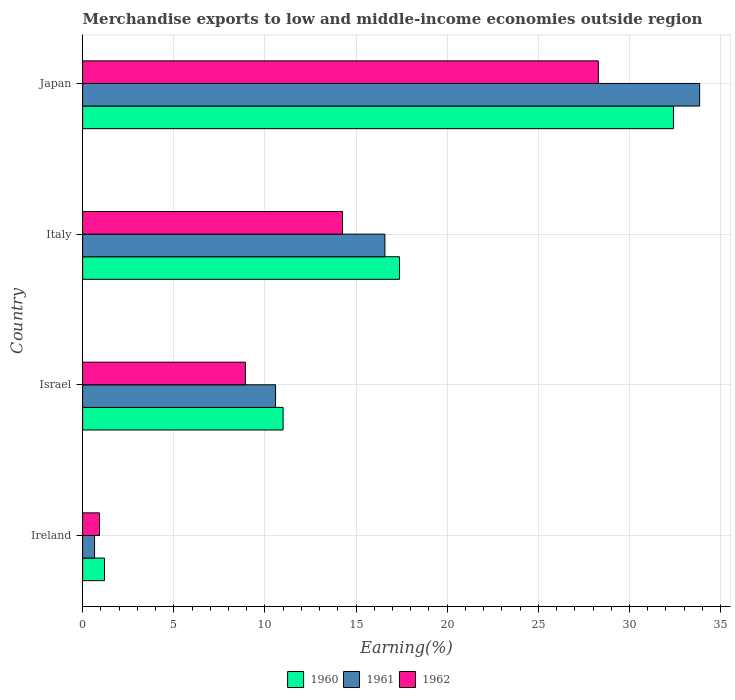How many different coloured bars are there?
Your answer should be compact. 3. Are the number of bars per tick equal to the number of legend labels?
Your answer should be compact. Yes. What is the label of the 3rd group of bars from the top?
Provide a succinct answer. Israel. What is the percentage of amount earned from merchandise exports in 1960 in Japan?
Offer a very short reply. 32.41. Across all countries, what is the maximum percentage of amount earned from merchandise exports in 1960?
Provide a succinct answer. 32.41. Across all countries, what is the minimum percentage of amount earned from merchandise exports in 1960?
Your response must be concise. 1.2. In which country was the percentage of amount earned from merchandise exports in 1962 minimum?
Your response must be concise. Ireland. What is the total percentage of amount earned from merchandise exports in 1961 in the graph?
Provide a short and direct response. 61.67. What is the difference between the percentage of amount earned from merchandise exports in 1962 in Ireland and that in Italy?
Provide a succinct answer. -13.33. What is the difference between the percentage of amount earned from merchandise exports in 1961 in Italy and the percentage of amount earned from merchandise exports in 1962 in Ireland?
Make the answer very short. 15.66. What is the average percentage of amount earned from merchandise exports in 1960 per country?
Provide a short and direct response. 15.5. What is the difference between the percentage of amount earned from merchandise exports in 1960 and percentage of amount earned from merchandise exports in 1961 in Japan?
Your answer should be very brief. -1.44. What is the ratio of the percentage of amount earned from merchandise exports in 1961 in Israel to that in Japan?
Give a very brief answer. 0.31. Is the percentage of amount earned from merchandise exports in 1961 in Italy less than that in Japan?
Your answer should be very brief. Yes. What is the difference between the highest and the second highest percentage of amount earned from merchandise exports in 1962?
Your answer should be compact. 14.04. What is the difference between the highest and the lowest percentage of amount earned from merchandise exports in 1962?
Make the answer very short. 27.37. In how many countries, is the percentage of amount earned from merchandise exports in 1961 greater than the average percentage of amount earned from merchandise exports in 1961 taken over all countries?
Provide a short and direct response. 2. Is the sum of the percentage of amount earned from merchandise exports in 1962 in Italy and Japan greater than the maximum percentage of amount earned from merchandise exports in 1961 across all countries?
Offer a very short reply. Yes. What does the 1st bar from the bottom in Japan represents?
Keep it short and to the point. 1960. Is it the case that in every country, the sum of the percentage of amount earned from merchandise exports in 1962 and percentage of amount earned from merchandise exports in 1960 is greater than the percentage of amount earned from merchandise exports in 1961?
Keep it short and to the point. Yes. Are all the bars in the graph horizontal?
Offer a terse response. Yes. How many countries are there in the graph?
Your answer should be compact. 4. What is the difference between two consecutive major ticks on the X-axis?
Make the answer very short. 5. Are the values on the major ticks of X-axis written in scientific E-notation?
Keep it short and to the point. No. Where does the legend appear in the graph?
Your response must be concise. Bottom center. How are the legend labels stacked?
Your answer should be compact. Horizontal. What is the title of the graph?
Your answer should be very brief. Merchandise exports to low and middle-income economies outside region. What is the label or title of the X-axis?
Make the answer very short. Earning(%). What is the label or title of the Y-axis?
Keep it short and to the point. Country. What is the Earning(%) of 1960 in Ireland?
Make the answer very short. 1.2. What is the Earning(%) in 1961 in Ireland?
Your answer should be compact. 0.65. What is the Earning(%) in 1962 in Ireland?
Your answer should be compact. 0.92. What is the Earning(%) of 1960 in Israel?
Give a very brief answer. 11. What is the Earning(%) in 1961 in Israel?
Your response must be concise. 10.58. What is the Earning(%) in 1962 in Israel?
Provide a short and direct response. 8.93. What is the Earning(%) of 1960 in Italy?
Offer a very short reply. 17.38. What is the Earning(%) of 1961 in Italy?
Make the answer very short. 16.58. What is the Earning(%) of 1962 in Italy?
Ensure brevity in your answer.  14.26. What is the Earning(%) in 1960 in Japan?
Keep it short and to the point. 32.41. What is the Earning(%) in 1961 in Japan?
Offer a terse response. 33.85. What is the Earning(%) in 1962 in Japan?
Ensure brevity in your answer.  28.29. Across all countries, what is the maximum Earning(%) in 1960?
Your answer should be very brief. 32.41. Across all countries, what is the maximum Earning(%) of 1961?
Your answer should be compact. 33.85. Across all countries, what is the maximum Earning(%) in 1962?
Your answer should be compact. 28.29. Across all countries, what is the minimum Earning(%) in 1960?
Keep it short and to the point. 1.2. Across all countries, what is the minimum Earning(%) in 1961?
Ensure brevity in your answer.  0.65. Across all countries, what is the minimum Earning(%) in 1962?
Keep it short and to the point. 0.92. What is the total Earning(%) of 1960 in the graph?
Keep it short and to the point. 62. What is the total Earning(%) in 1961 in the graph?
Your answer should be very brief. 61.67. What is the total Earning(%) in 1962 in the graph?
Keep it short and to the point. 52.4. What is the difference between the Earning(%) of 1960 in Ireland and that in Israel?
Keep it short and to the point. -9.8. What is the difference between the Earning(%) of 1961 in Ireland and that in Israel?
Your answer should be compact. -9.93. What is the difference between the Earning(%) of 1962 in Ireland and that in Israel?
Keep it short and to the point. -8. What is the difference between the Earning(%) in 1960 in Ireland and that in Italy?
Give a very brief answer. -16.19. What is the difference between the Earning(%) of 1961 in Ireland and that in Italy?
Keep it short and to the point. -15.93. What is the difference between the Earning(%) of 1962 in Ireland and that in Italy?
Your response must be concise. -13.33. What is the difference between the Earning(%) of 1960 in Ireland and that in Japan?
Ensure brevity in your answer.  -31.21. What is the difference between the Earning(%) of 1961 in Ireland and that in Japan?
Make the answer very short. -33.2. What is the difference between the Earning(%) in 1962 in Ireland and that in Japan?
Offer a terse response. -27.37. What is the difference between the Earning(%) of 1960 in Israel and that in Italy?
Provide a short and direct response. -6.39. What is the difference between the Earning(%) in 1961 in Israel and that in Italy?
Give a very brief answer. -6. What is the difference between the Earning(%) in 1962 in Israel and that in Italy?
Your response must be concise. -5.33. What is the difference between the Earning(%) of 1960 in Israel and that in Japan?
Give a very brief answer. -21.42. What is the difference between the Earning(%) in 1961 in Israel and that in Japan?
Your answer should be very brief. -23.27. What is the difference between the Earning(%) of 1962 in Israel and that in Japan?
Your response must be concise. -19.37. What is the difference between the Earning(%) of 1960 in Italy and that in Japan?
Your response must be concise. -15.03. What is the difference between the Earning(%) of 1961 in Italy and that in Japan?
Ensure brevity in your answer.  -17.27. What is the difference between the Earning(%) of 1962 in Italy and that in Japan?
Ensure brevity in your answer.  -14.04. What is the difference between the Earning(%) of 1960 in Ireland and the Earning(%) of 1961 in Israel?
Your answer should be very brief. -9.39. What is the difference between the Earning(%) of 1960 in Ireland and the Earning(%) of 1962 in Israel?
Your response must be concise. -7.73. What is the difference between the Earning(%) of 1961 in Ireland and the Earning(%) of 1962 in Israel?
Your answer should be very brief. -8.27. What is the difference between the Earning(%) in 1960 in Ireland and the Earning(%) in 1961 in Italy?
Keep it short and to the point. -15.38. What is the difference between the Earning(%) in 1960 in Ireland and the Earning(%) in 1962 in Italy?
Your response must be concise. -13.06. What is the difference between the Earning(%) in 1961 in Ireland and the Earning(%) in 1962 in Italy?
Your answer should be compact. -13.6. What is the difference between the Earning(%) of 1960 in Ireland and the Earning(%) of 1961 in Japan?
Ensure brevity in your answer.  -32.65. What is the difference between the Earning(%) of 1960 in Ireland and the Earning(%) of 1962 in Japan?
Make the answer very short. -27.09. What is the difference between the Earning(%) in 1961 in Ireland and the Earning(%) in 1962 in Japan?
Your response must be concise. -27.64. What is the difference between the Earning(%) of 1960 in Israel and the Earning(%) of 1961 in Italy?
Give a very brief answer. -5.59. What is the difference between the Earning(%) of 1960 in Israel and the Earning(%) of 1962 in Italy?
Keep it short and to the point. -3.26. What is the difference between the Earning(%) in 1961 in Israel and the Earning(%) in 1962 in Italy?
Offer a terse response. -3.67. What is the difference between the Earning(%) in 1960 in Israel and the Earning(%) in 1961 in Japan?
Provide a succinct answer. -22.85. What is the difference between the Earning(%) of 1960 in Israel and the Earning(%) of 1962 in Japan?
Give a very brief answer. -17.3. What is the difference between the Earning(%) of 1961 in Israel and the Earning(%) of 1962 in Japan?
Offer a terse response. -17.71. What is the difference between the Earning(%) in 1960 in Italy and the Earning(%) in 1961 in Japan?
Give a very brief answer. -16.47. What is the difference between the Earning(%) in 1960 in Italy and the Earning(%) in 1962 in Japan?
Your answer should be very brief. -10.91. What is the difference between the Earning(%) in 1961 in Italy and the Earning(%) in 1962 in Japan?
Offer a terse response. -11.71. What is the average Earning(%) in 1960 per country?
Your answer should be very brief. 15.5. What is the average Earning(%) in 1961 per country?
Provide a short and direct response. 15.42. What is the average Earning(%) of 1962 per country?
Make the answer very short. 13.1. What is the difference between the Earning(%) in 1960 and Earning(%) in 1961 in Ireland?
Provide a short and direct response. 0.54. What is the difference between the Earning(%) of 1960 and Earning(%) of 1962 in Ireland?
Ensure brevity in your answer.  0.27. What is the difference between the Earning(%) in 1961 and Earning(%) in 1962 in Ireland?
Your response must be concise. -0.27. What is the difference between the Earning(%) in 1960 and Earning(%) in 1961 in Israel?
Ensure brevity in your answer.  0.41. What is the difference between the Earning(%) in 1960 and Earning(%) in 1962 in Israel?
Give a very brief answer. 2.07. What is the difference between the Earning(%) of 1961 and Earning(%) of 1962 in Israel?
Offer a terse response. 1.66. What is the difference between the Earning(%) of 1960 and Earning(%) of 1961 in Italy?
Your response must be concise. 0.8. What is the difference between the Earning(%) of 1960 and Earning(%) of 1962 in Italy?
Offer a very short reply. 3.13. What is the difference between the Earning(%) in 1961 and Earning(%) in 1962 in Italy?
Make the answer very short. 2.33. What is the difference between the Earning(%) in 1960 and Earning(%) in 1961 in Japan?
Keep it short and to the point. -1.44. What is the difference between the Earning(%) of 1960 and Earning(%) of 1962 in Japan?
Your answer should be compact. 4.12. What is the difference between the Earning(%) in 1961 and Earning(%) in 1962 in Japan?
Offer a terse response. 5.56. What is the ratio of the Earning(%) in 1960 in Ireland to that in Israel?
Your answer should be compact. 0.11. What is the ratio of the Earning(%) in 1961 in Ireland to that in Israel?
Your answer should be compact. 0.06. What is the ratio of the Earning(%) in 1962 in Ireland to that in Israel?
Ensure brevity in your answer.  0.1. What is the ratio of the Earning(%) in 1960 in Ireland to that in Italy?
Make the answer very short. 0.07. What is the ratio of the Earning(%) in 1961 in Ireland to that in Italy?
Keep it short and to the point. 0.04. What is the ratio of the Earning(%) in 1962 in Ireland to that in Italy?
Give a very brief answer. 0.06. What is the ratio of the Earning(%) in 1960 in Ireland to that in Japan?
Keep it short and to the point. 0.04. What is the ratio of the Earning(%) in 1961 in Ireland to that in Japan?
Ensure brevity in your answer.  0.02. What is the ratio of the Earning(%) of 1962 in Ireland to that in Japan?
Provide a short and direct response. 0.03. What is the ratio of the Earning(%) in 1960 in Israel to that in Italy?
Ensure brevity in your answer.  0.63. What is the ratio of the Earning(%) in 1961 in Israel to that in Italy?
Offer a terse response. 0.64. What is the ratio of the Earning(%) in 1962 in Israel to that in Italy?
Offer a terse response. 0.63. What is the ratio of the Earning(%) in 1960 in Israel to that in Japan?
Ensure brevity in your answer.  0.34. What is the ratio of the Earning(%) in 1961 in Israel to that in Japan?
Keep it short and to the point. 0.31. What is the ratio of the Earning(%) in 1962 in Israel to that in Japan?
Make the answer very short. 0.32. What is the ratio of the Earning(%) of 1960 in Italy to that in Japan?
Keep it short and to the point. 0.54. What is the ratio of the Earning(%) of 1961 in Italy to that in Japan?
Offer a terse response. 0.49. What is the ratio of the Earning(%) in 1962 in Italy to that in Japan?
Your answer should be very brief. 0.5. What is the difference between the highest and the second highest Earning(%) of 1960?
Keep it short and to the point. 15.03. What is the difference between the highest and the second highest Earning(%) of 1961?
Ensure brevity in your answer.  17.27. What is the difference between the highest and the second highest Earning(%) of 1962?
Offer a terse response. 14.04. What is the difference between the highest and the lowest Earning(%) in 1960?
Ensure brevity in your answer.  31.21. What is the difference between the highest and the lowest Earning(%) of 1961?
Your answer should be compact. 33.2. What is the difference between the highest and the lowest Earning(%) in 1962?
Your answer should be very brief. 27.37. 